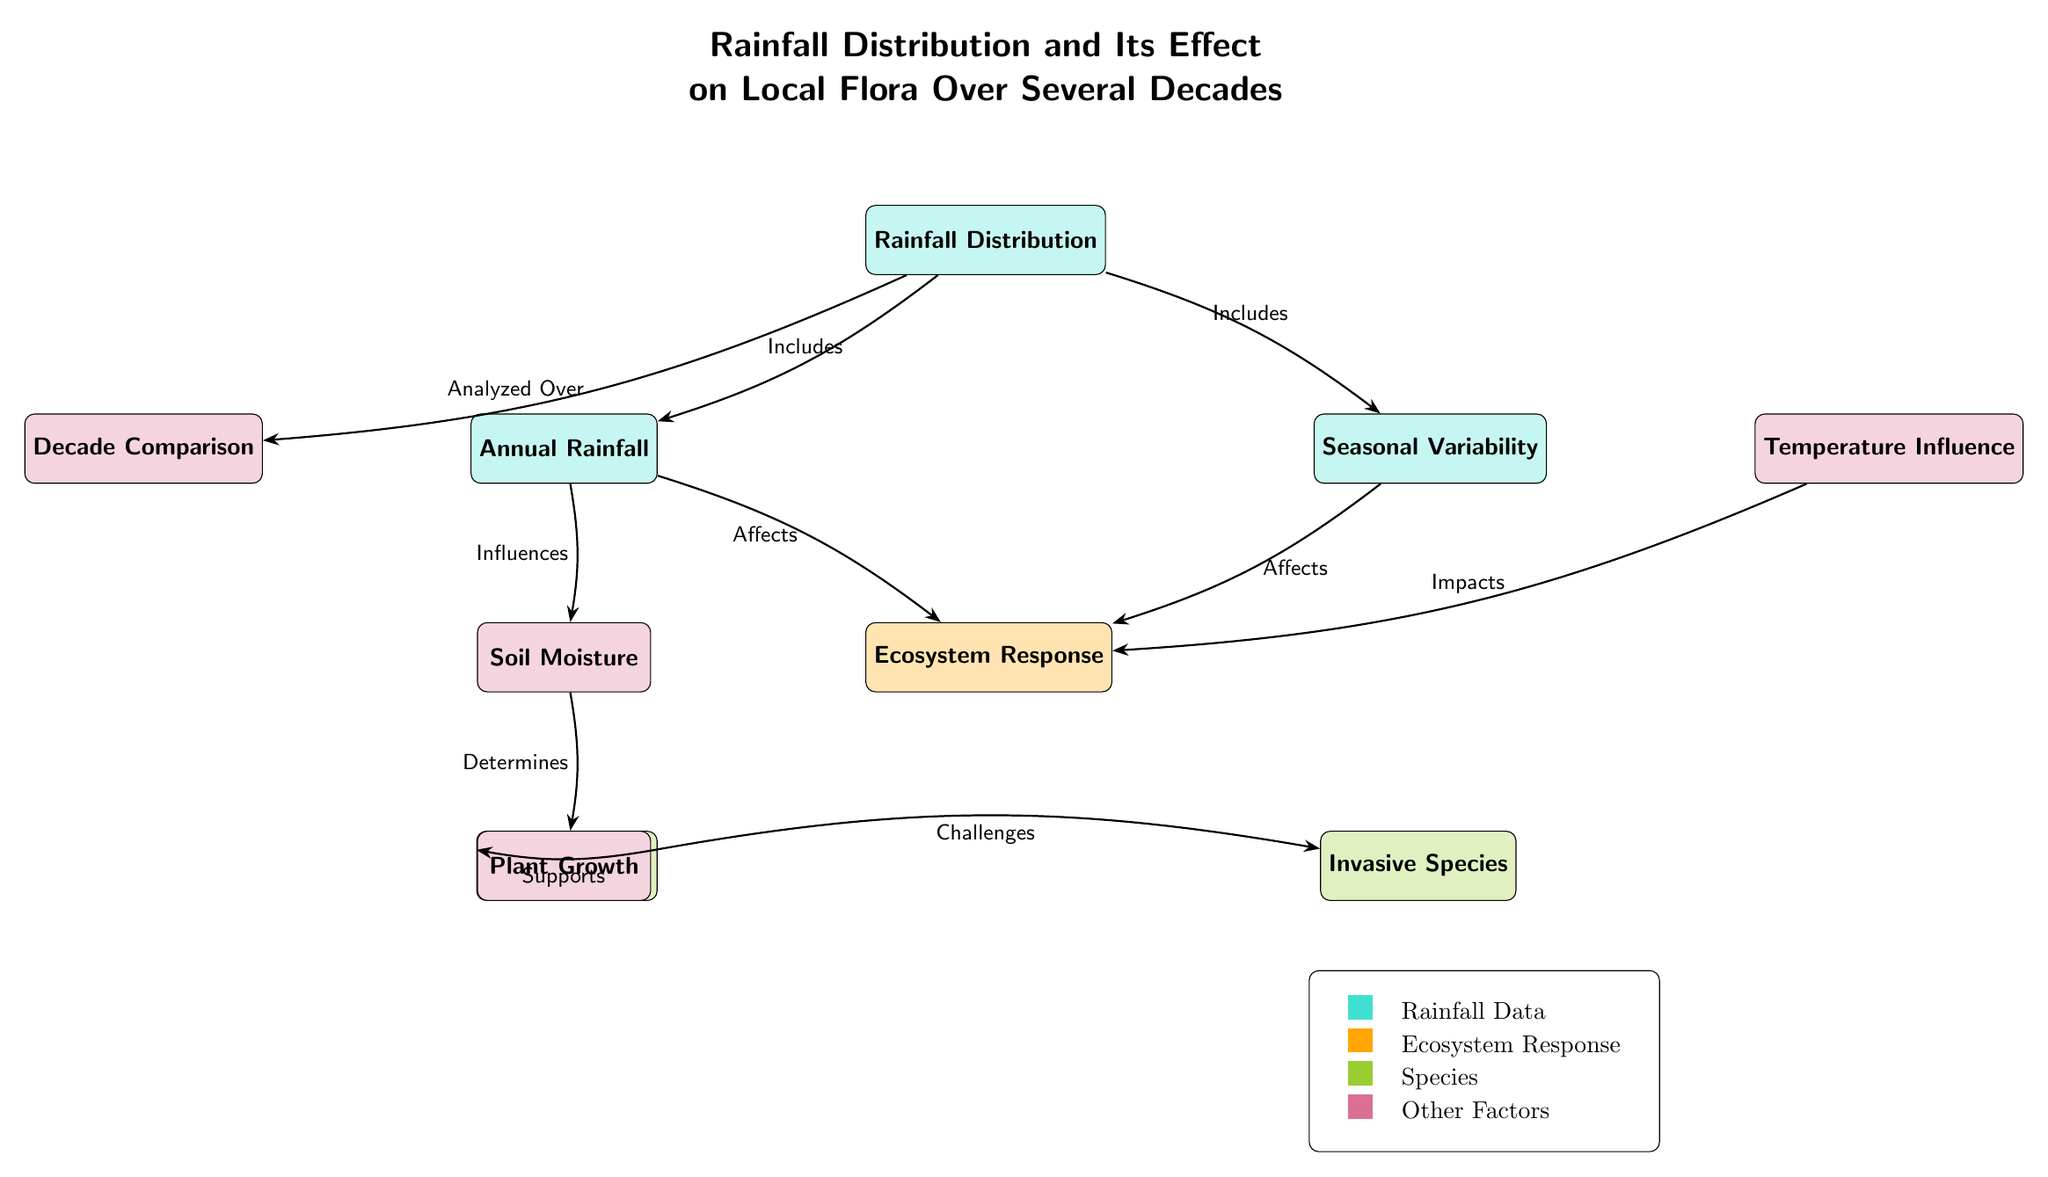What are the two main components included under Rainfall Distribution? The diagram shows that under Rainfall Distribution, there are two main components: Annual Rainfall and Seasonal Variability. These are directly connected to the Rainfall Distribution node.
Answer: Annual Rainfall and Seasonal Variability How does Annual Rainfall affect Ecosystem Response? According to the diagram, Annual Rainfall directly affects Ecosystem Response. This connection is represented by an arrow pointing from Annual Rainfall to Ecosystem Response.
Answer: Affects What does Soil Moisture determine? The diagram illustrates that Soil Moisture determines Plant Growth, as depicted by the arrow from the Soil Moisture node to the Plant Growth node.
Answer: Plant Growth What species does Plant Growth support? The diagram indicates that Plant Growth supports Native Species, which is shown by the arrow leading from Plant Growth to Native Species.
Answer: Native Species Which factor impacts Ecosystem Response besides Rainfall Distribution? The diagram specifies that Temperature Influence also impacts Ecosystem Response, as shown by an arrow pointing from the Temperature Influence node to the Ecosystem Response node.
Answer: Temperature Influence Is there a direct relationship between Seasonal Variability and Soil Moisture? No, the diagram does not show a direct relationship between Seasonal Variability and Soil Moisture. Instead, it shows that Seasonal Variability affects Ecosystem Response, and Annual Rainfall is the one that influences Soil Moisture.
Answer: No What color represents Rainfall Data in the legend? The legend indicates that Rainfall Data is represented by the color cyan (rainfallColor), as depicted by the corresponding box with the color next to the label.
Answer: Cyan How many nodes are directly connected to Ecosystem Response? The diagram indicates that there are three nodes directly connected to Ecosystem Response: Annual Rainfall, Seasonal Variability, and Temperature Influence.
Answer: Three What challenges does Plant Growth face according to the diagram? Plant Growth faces challenges from Invasive Species, as illustrated by the arrow pointing from Plant Growth to Invasive Species indicating a negative relationship.
Answer: Invasive Species 